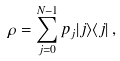Convert formula to latex. <formula><loc_0><loc_0><loc_500><loc_500>\rho = \sum _ { j = 0 } ^ { N - 1 } p _ { j } | j \rangle \langle j | \, ,</formula> 